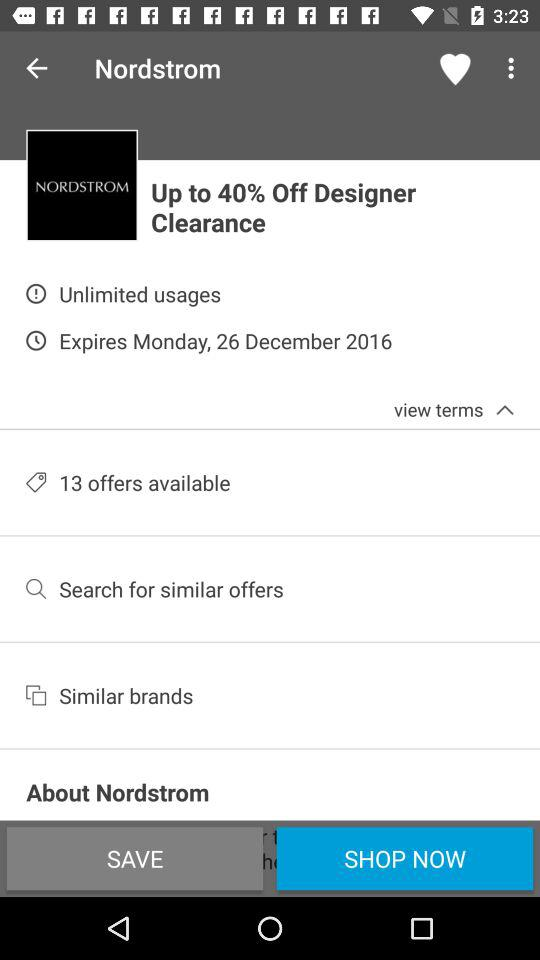How many offers are available? There are 13 offers available. 